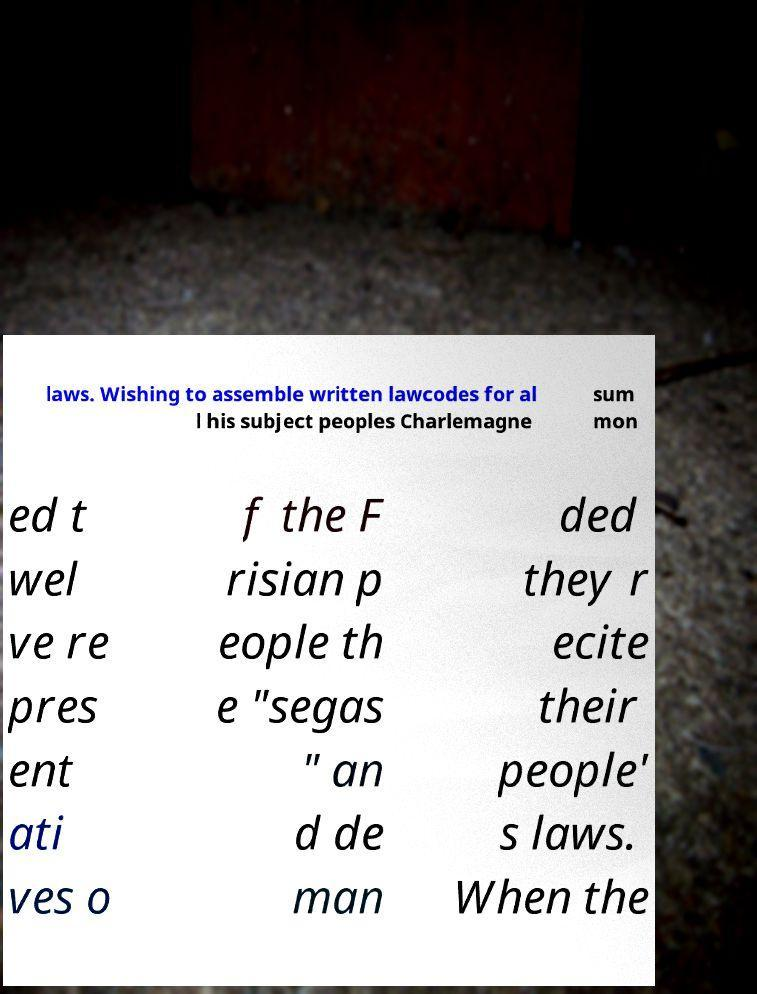Could you extract and type out the text from this image? laws. Wishing to assemble written lawcodes for al l his subject peoples Charlemagne sum mon ed t wel ve re pres ent ati ves o f the F risian p eople th e "segas " an d de man ded they r ecite their people' s laws. When the 